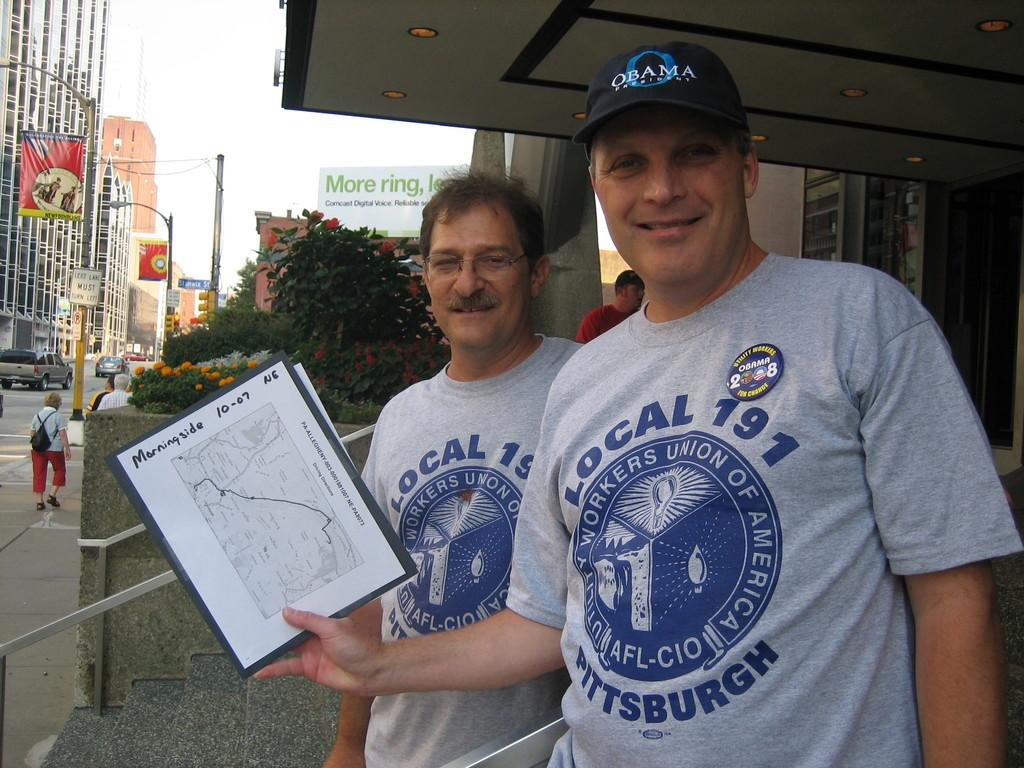<image>
Summarize the visual content of the image. two men wearing local 191 shirts on themselves 